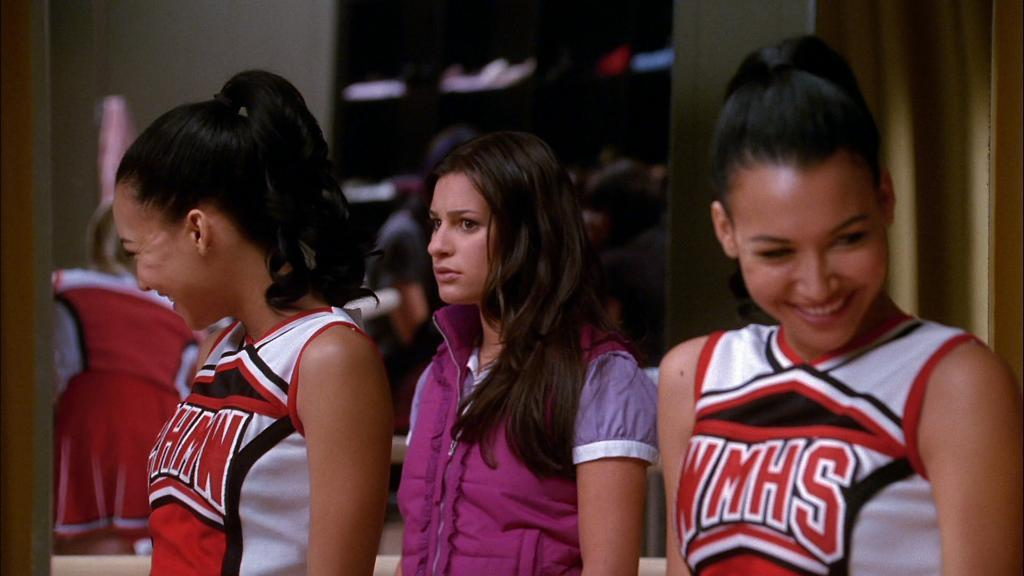Provide a one-sentence caption for the provided image. A cheerleader from WMHS turns her head and laughs. 